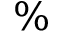<formula> <loc_0><loc_0><loc_500><loc_500>\%</formula> 